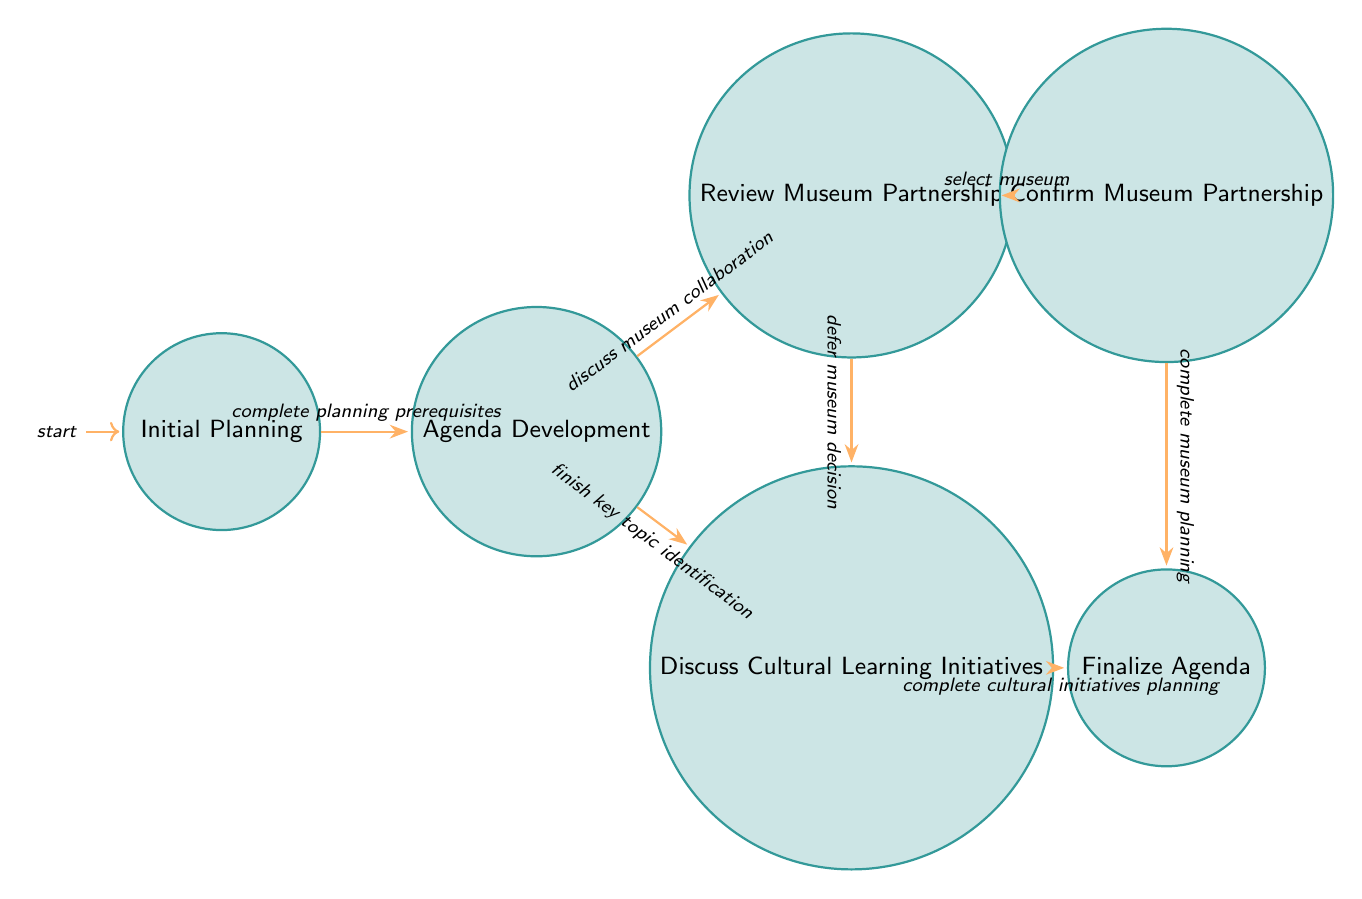What is the first state in the diagram? The diagram starts at the "Initial Planning" state, which is visually indicated as the first node.
Answer: Initial Planning How many states are in the diagram? By counting each distinct node in the diagram, there are a total of six states.
Answer: 6 What action is associated with the "Agenda Development" state? In the "Agenda Development" state, several actions are listed, including "Gather agenda input from PTA members," indicating this is the correct answer.
Answer: Gather agenda input from PTA members What is the transition event from "Review Museum Partnership" to "Confirm Museum Partnership"? The transition in the diagram from "Review Museum Partnership" to "Confirm Museum Partnership" is labeled as "select museum," taking this directly from the connecting edge.
Answer: select museum What is the last state that can be reached from "Agenda Development"? From the "Agenda Development" state, the path leads to either "Review Museum Partnership" or "Discuss Cultural Learning Initiatives," but both eventually allow a transition to "Finalize Agenda," which is the ultimate last state to be reached.
Answer: Finalize Agenda Which state does "Confirm Museum Partnership" connect to next? The only transition available from the "Confirm Museum Partnership" state leads to the "Finalize Agenda," which is shown by the arrow in the diagram connecting them directly.
Answer: Finalize Agenda What happens if the decision is deferred in "Review Museum Partnership"? If the decision is deferred, then the next state reached would be "Discuss Cultural Learning Initiatives," indicated by the diagram’s arrow pointing in that direction.
Answer: Discuss Cultural Learning Initiatives Identify an action that takes place during "Discuss Cultural Learning Initiatives." An action listed in the "Discuss Cultural Learning Initiatives" state is "Brainstorm new cultural learning activities," which directly reflects the contents shown in that state.
Answer: Brainstorm new cultural learning activities 